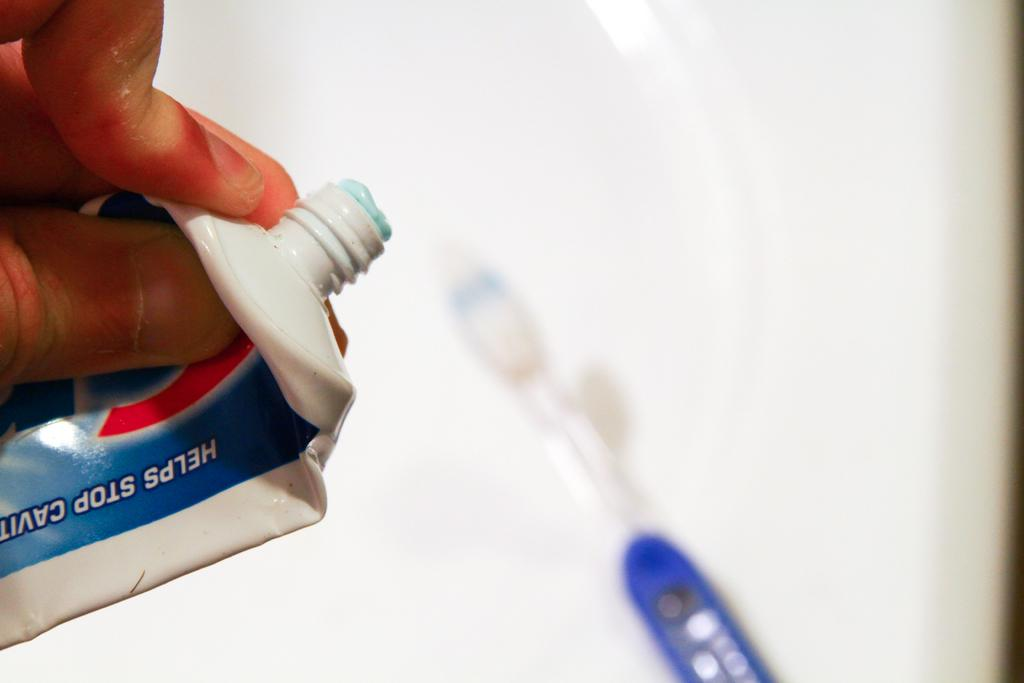What is the main object in the center of the image? There is a brush in the center of the image. What is the person's hand holding in the background? There is a person's hand holding toothpaste in the background. What can be seen at the bottom of the image? There is a sink at the bottom of the image. What type of writing can be seen on the brush in the image? There is no writing visible on the brush in the image. How many wheels are present on the brush in the image? The brush in the image does not have any wheels. 